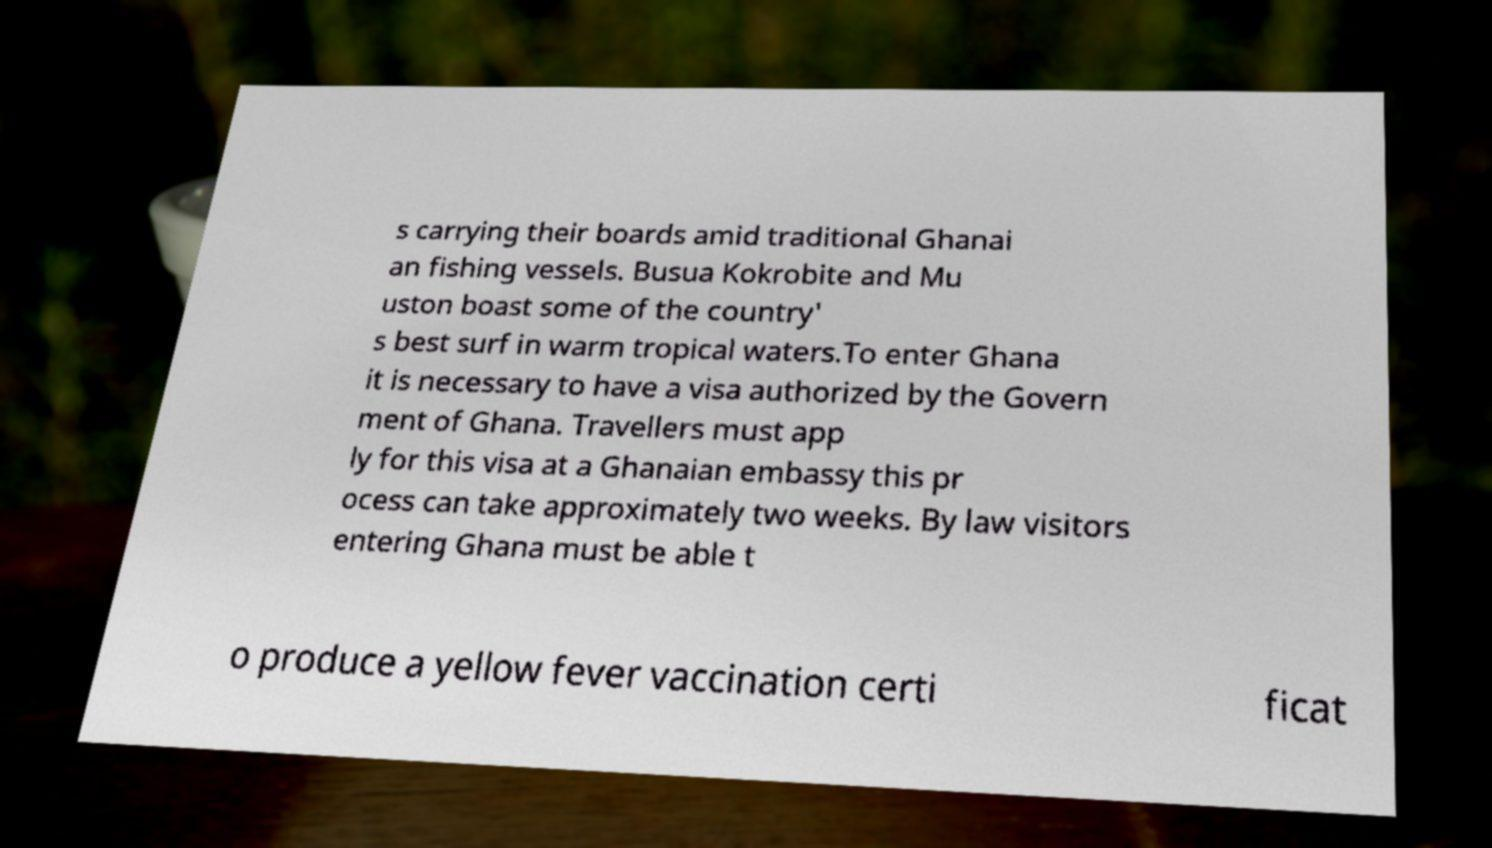Can you accurately transcribe the text from the provided image for me? s carrying their boards amid traditional Ghanai an fishing vessels. Busua Kokrobite and Mu uston boast some of the country' s best surf in warm tropical waters.To enter Ghana it is necessary to have a visa authorized by the Govern ment of Ghana. Travellers must app ly for this visa at a Ghanaian embassy this pr ocess can take approximately two weeks. By law visitors entering Ghana must be able t o produce a yellow fever vaccination certi ficat 